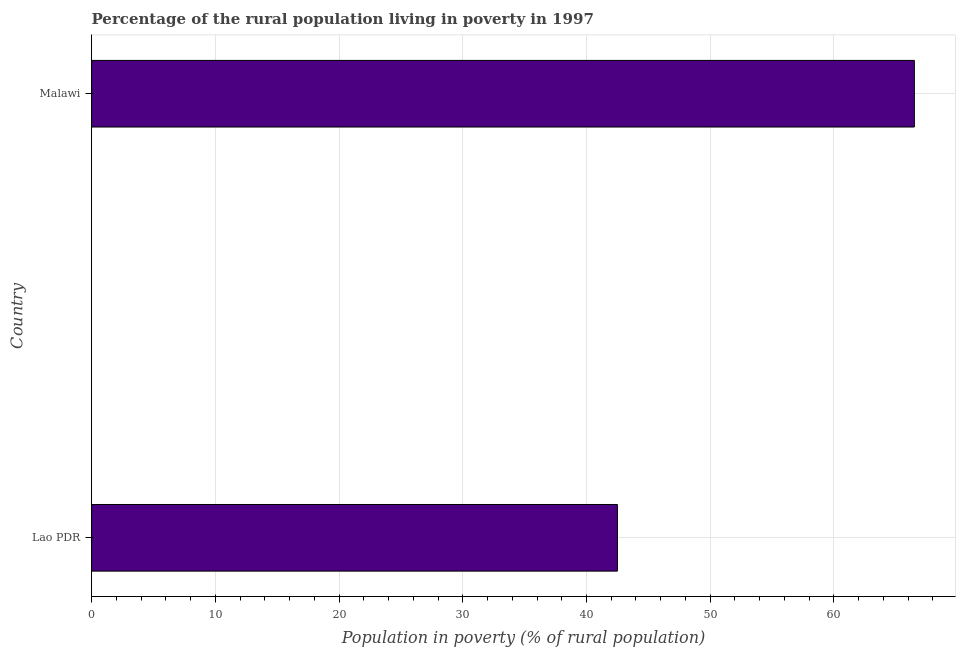Does the graph contain grids?
Provide a short and direct response. Yes. What is the title of the graph?
Your response must be concise. Percentage of the rural population living in poverty in 1997. What is the label or title of the X-axis?
Give a very brief answer. Population in poverty (% of rural population). What is the percentage of rural population living below poverty line in Malawi?
Your answer should be compact. 66.5. Across all countries, what is the maximum percentage of rural population living below poverty line?
Give a very brief answer. 66.5. Across all countries, what is the minimum percentage of rural population living below poverty line?
Offer a very short reply. 42.5. In which country was the percentage of rural population living below poverty line maximum?
Give a very brief answer. Malawi. In which country was the percentage of rural population living below poverty line minimum?
Provide a short and direct response. Lao PDR. What is the sum of the percentage of rural population living below poverty line?
Make the answer very short. 109. What is the average percentage of rural population living below poverty line per country?
Offer a terse response. 54.5. What is the median percentage of rural population living below poverty line?
Provide a short and direct response. 54.5. In how many countries, is the percentage of rural population living below poverty line greater than 44 %?
Provide a short and direct response. 1. What is the ratio of the percentage of rural population living below poverty line in Lao PDR to that in Malawi?
Ensure brevity in your answer.  0.64. Is the percentage of rural population living below poverty line in Lao PDR less than that in Malawi?
Keep it short and to the point. Yes. In how many countries, is the percentage of rural population living below poverty line greater than the average percentage of rural population living below poverty line taken over all countries?
Make the answer very short. 1. How many countries are there in the graph?
Keep it short and to the point. 2. Are the values on the major ticks of X-axis written in scientific E-notation?
Keep it short and to the point. No. What is the Population in poverty (% of rural population) of Lao PDR?
Your answer should be compact. 42.5. What is the Population in poverty (% of rural population) of Malawi?
Offer a very short reply. 66.5. What is the ratio of the Population in poverty (% of rural population) in Lao PDR to that in Malawi?
Your response must be concise. 0.64. 